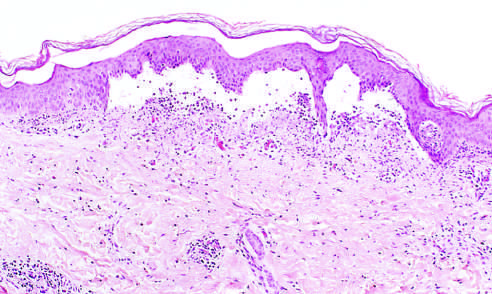s low-power view of a cross section of a skin blister showing the epidermis separated from the dermis by a focal collection of serous effusion?
Answer the question using a single word or phrase. Yes 